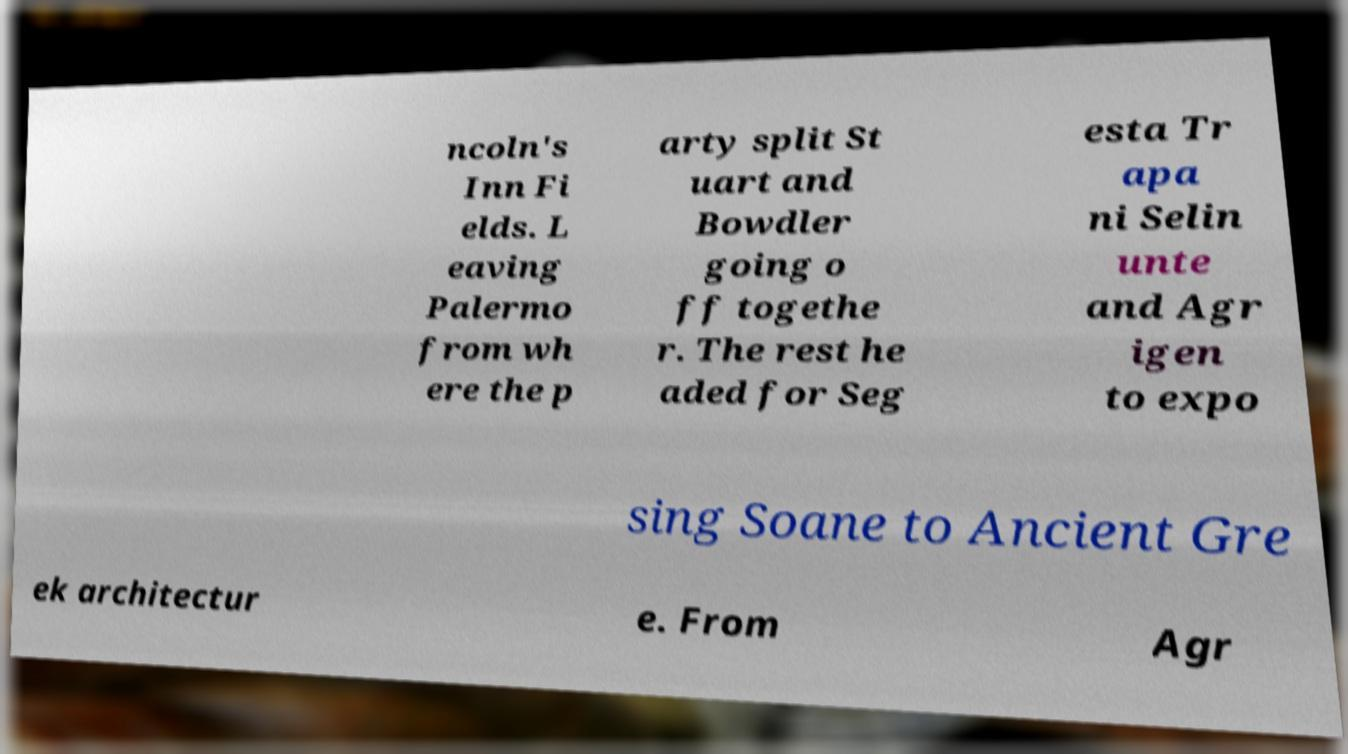I need the written content from this picture converted into text. Can you do that? ncoln's Inn Fi elds. L eaving Palermo from wh ere the p arty split St uart and Bowdler going o ff togethe r. The rest he aded for Seg esta Tr apa ni Selin unte and Agr igen to expo sing Soane to Ancient Gre ek architectur e. From Agr 